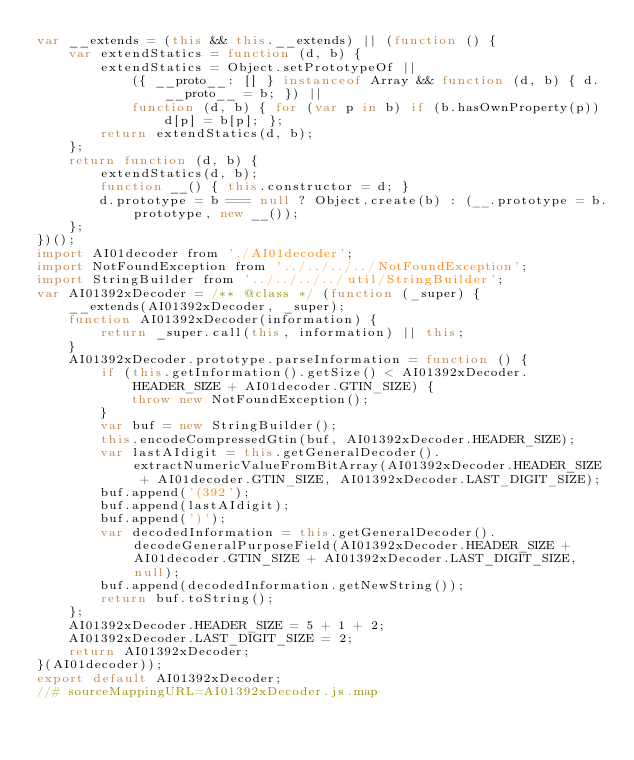<code> <loc_0><loc_0><loc_500><loc_500><_JavaScript_>var __extends = (this && this.__extends) || (function () {
    var extendStatics = function (d, b) {
        extendStatics = Object.setPrototypeOf ||
            ({ __proto__: [] } instanceof Array && function (d, b) { d.__proto__ = b; }) ||
            function (d, b) { for (var p in b) if (b.hasOwnProperty(p)) d[p] = b[p]; };
        return extendStatics(d, b);
    };
    return function (d, b) {
        extendStatics(d, b);
        function __() { this.constructor = d; }
        d.prototype = b === null ? Object.create(b) : (__.prototype = b.prototype, new __());
    };
})();
import AI01decoder from './AI01decoder';
import NotFoundException from '../../../../NotFoundException';
import StringBuilder from '../../../../util/StringBuilder';
var AI01392xDecoder = /** @class */ (function (_super) {
    __extends(AI01392xDecoder, _super);
    function AI01392xDecoder(information) {
        return _super.call(this, information) || this;
    }
    AI01392xDecoder.prototype.parseInformation = function () {
        if (this.getInformation().getSize() < AI01392xDecoder.HEADER_SIZE + AI01decoder.GTIN_SIZE) {
            throw new NotFoundException();
        }
        var buf = new StringBuilder();
        this.encodeCompressedGtin(buf, AI01392xDecoder.HEADER_SIZE);
        var lastAIdigit = this.getGeneralDecoder().extractNumericValueFromBitArray(AI01392xDecoder.HEADER_SIZE + AI01decoder.GTIN_SIZE, AI01392xDecoder.LAST_DIGIT_SIZE);
        buf.append('(392');
        buf.append(lastAIdigit);
        buf.append(')');
        var decodedInformation = this.getGeneralDecoder().decodeGeneralPurposeField(AI01392xDecoder.HEADER_SIZE + AI01decoder.GTIN_SIZE + AI01392xDecoder.LAST_DIGIT_SIZE, null);
        buf.append(decodedInformation.getNewString());
        return buf.toString();
    };
    AI01392xDecoder.HEADER_SIZE = 5 + 1 + 2;
    AI01392xDecoder.LAST_DIGIT_SIZE = 2;
    return AI01392xDecoder;
}(AI01decoder));
export default AI01392xDecoder;
//# sourceMappingURL=AI01392xDecoder.js.map</code> 